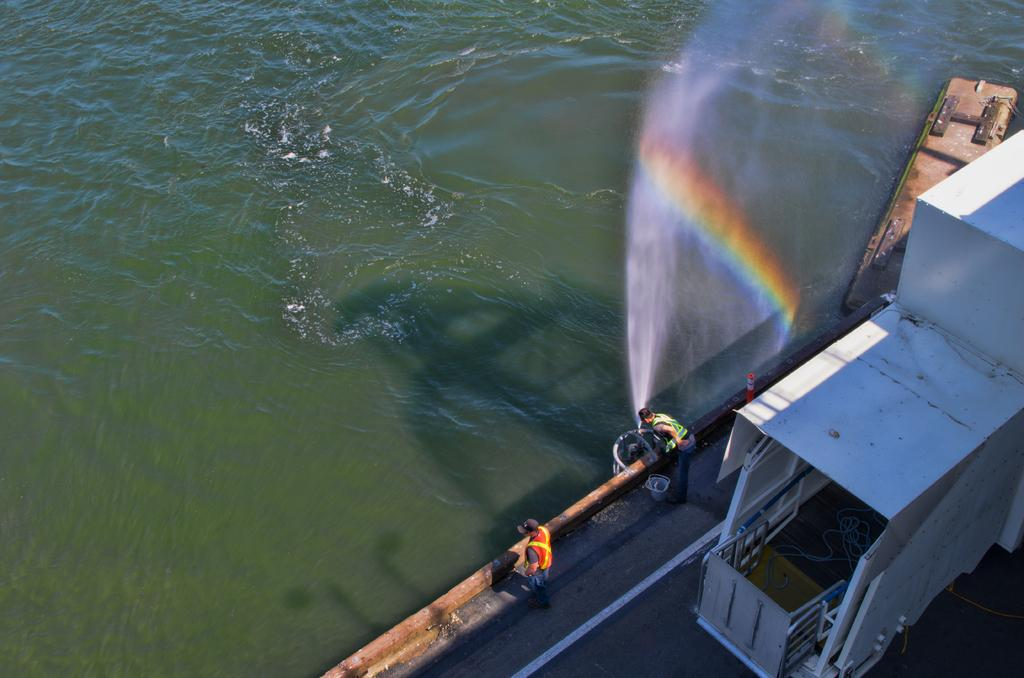What natural feature is present in the picture? There is a river in the picture. Who or what else can be seen in the picture? There are people in the picture. What additional feature is present in the sky? There is a rainbow in the picture. What type of badge can be seen on the river in the picture? There is no badge present on the river in the image. What material is the iron used for in the picture? There is no iron or iron-related activity depicted in the image. 